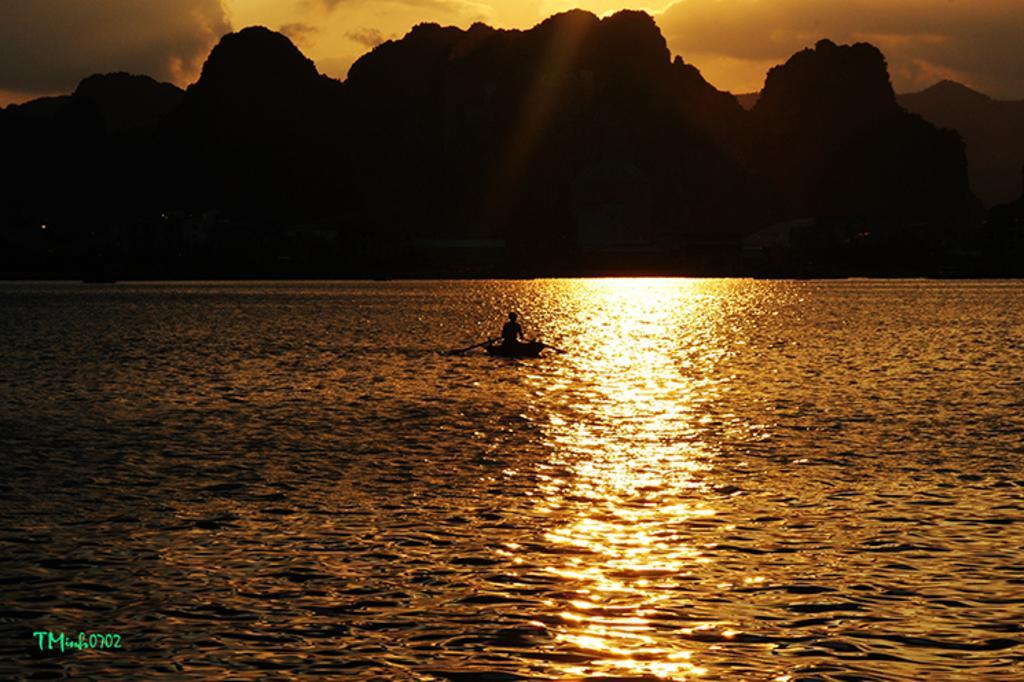Can you describe this image briefly? In this image I can see the water and on it I can see a boat and a person sitting on a boat. In the background I can see few trees, few mountains and the sky. 